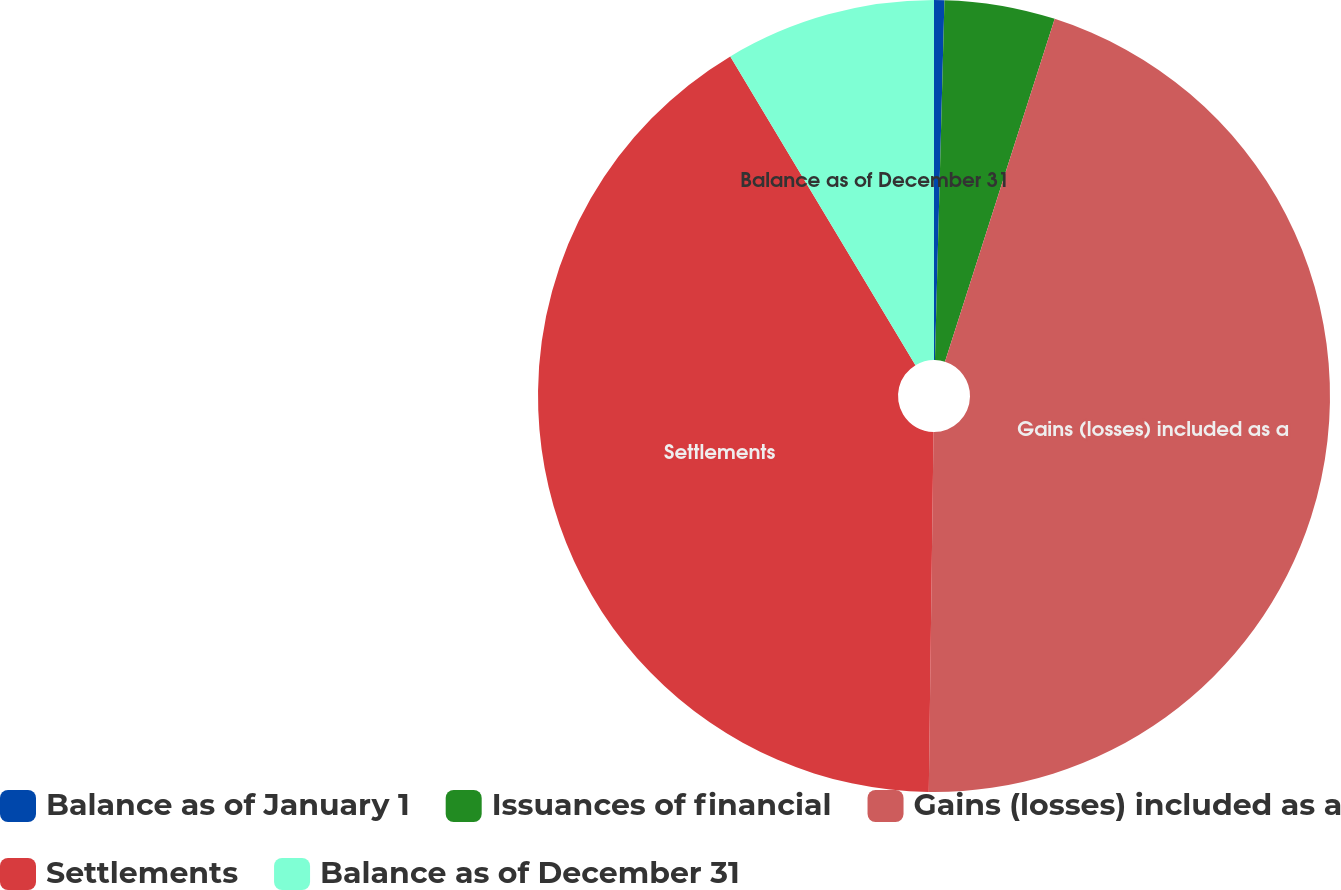Convert chart to OTSL. <chart><loc_0><loc_0><loc_500><loc_500><pie_chart><fcel>Balance as of January 1<fcel>Issuances of financial<fcel>Gains (losses) included as a<fcel>Settlements<fcel>Balance as of December 31<nl><fcel>0.42%<fcel>4.51%<fcel>45.28%<fcel>41.19%<fcel>8.6%<nl></chart> 